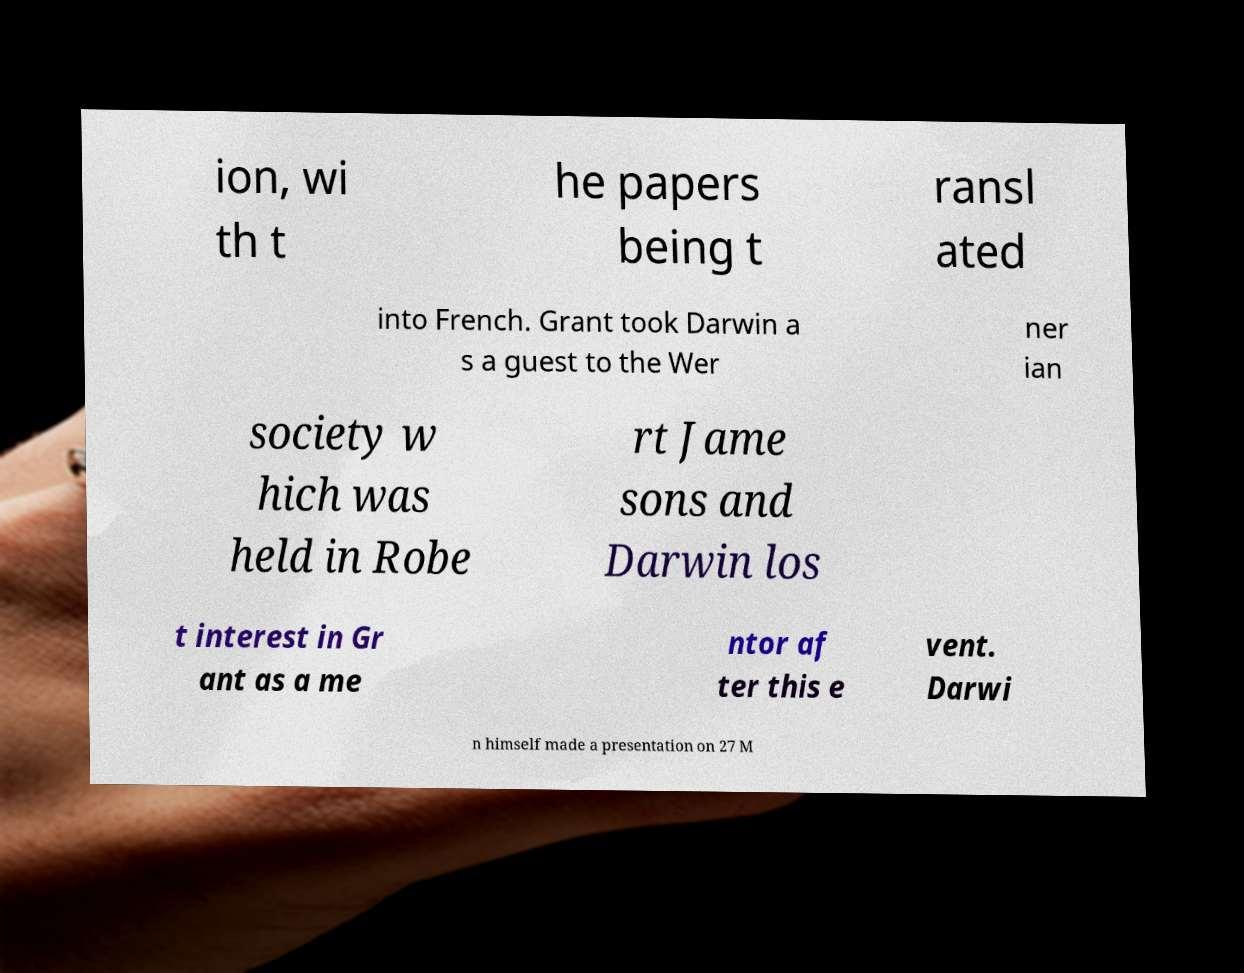Could you assist in decoding the text presented in this image and type it out clearly? ion, wi th t he papers being t ransl ated into French. Grant took Darwin a s a guest to the Wer ner ian society w hich was held in Robe rt Jame sons and Darwin los t interest in Gr ant as a me ntor af ter this e vent. Darwi n himself made a presentation on 27 M 